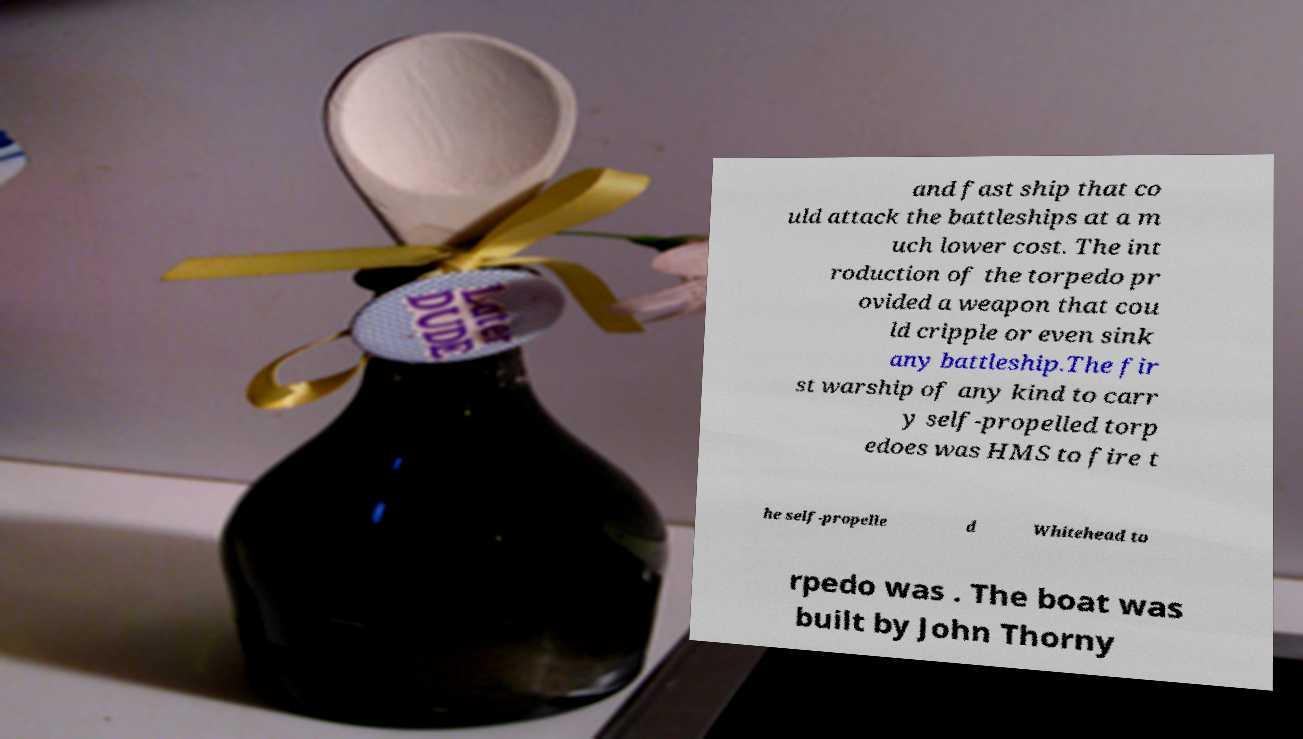I need the written content from this picture converted into text. Can you do that? and fast ship that co uld attack the battleships at a m uch lower cost. The int roduction of the torpedo pr ovided a weapon that cou ld cripple or even sink any battleship.The fir st warship of any kind to carr y self-propelled torp edoes was HMS to fire t he self-propelle d Whitehead to rpedo was . The boat was built by John Thorny 